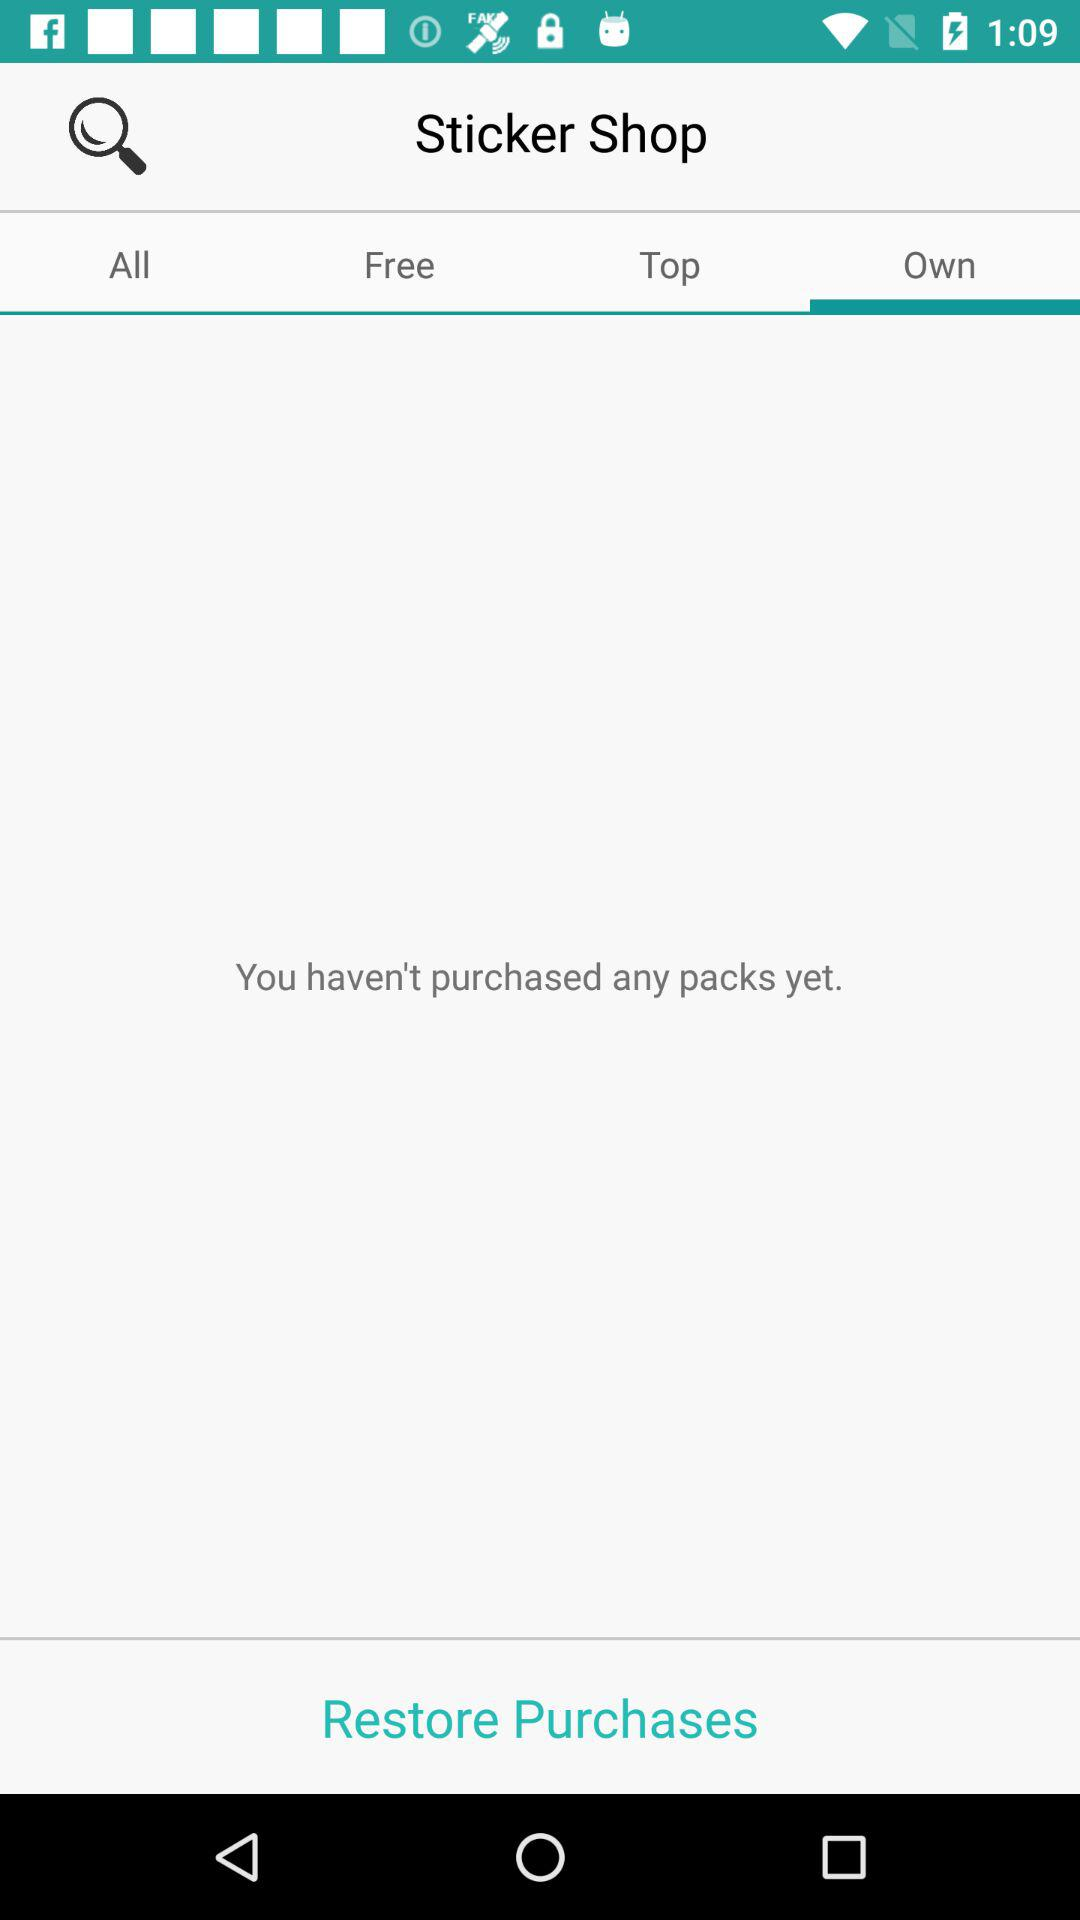Which tab is selected? The selected tab is "Own". 